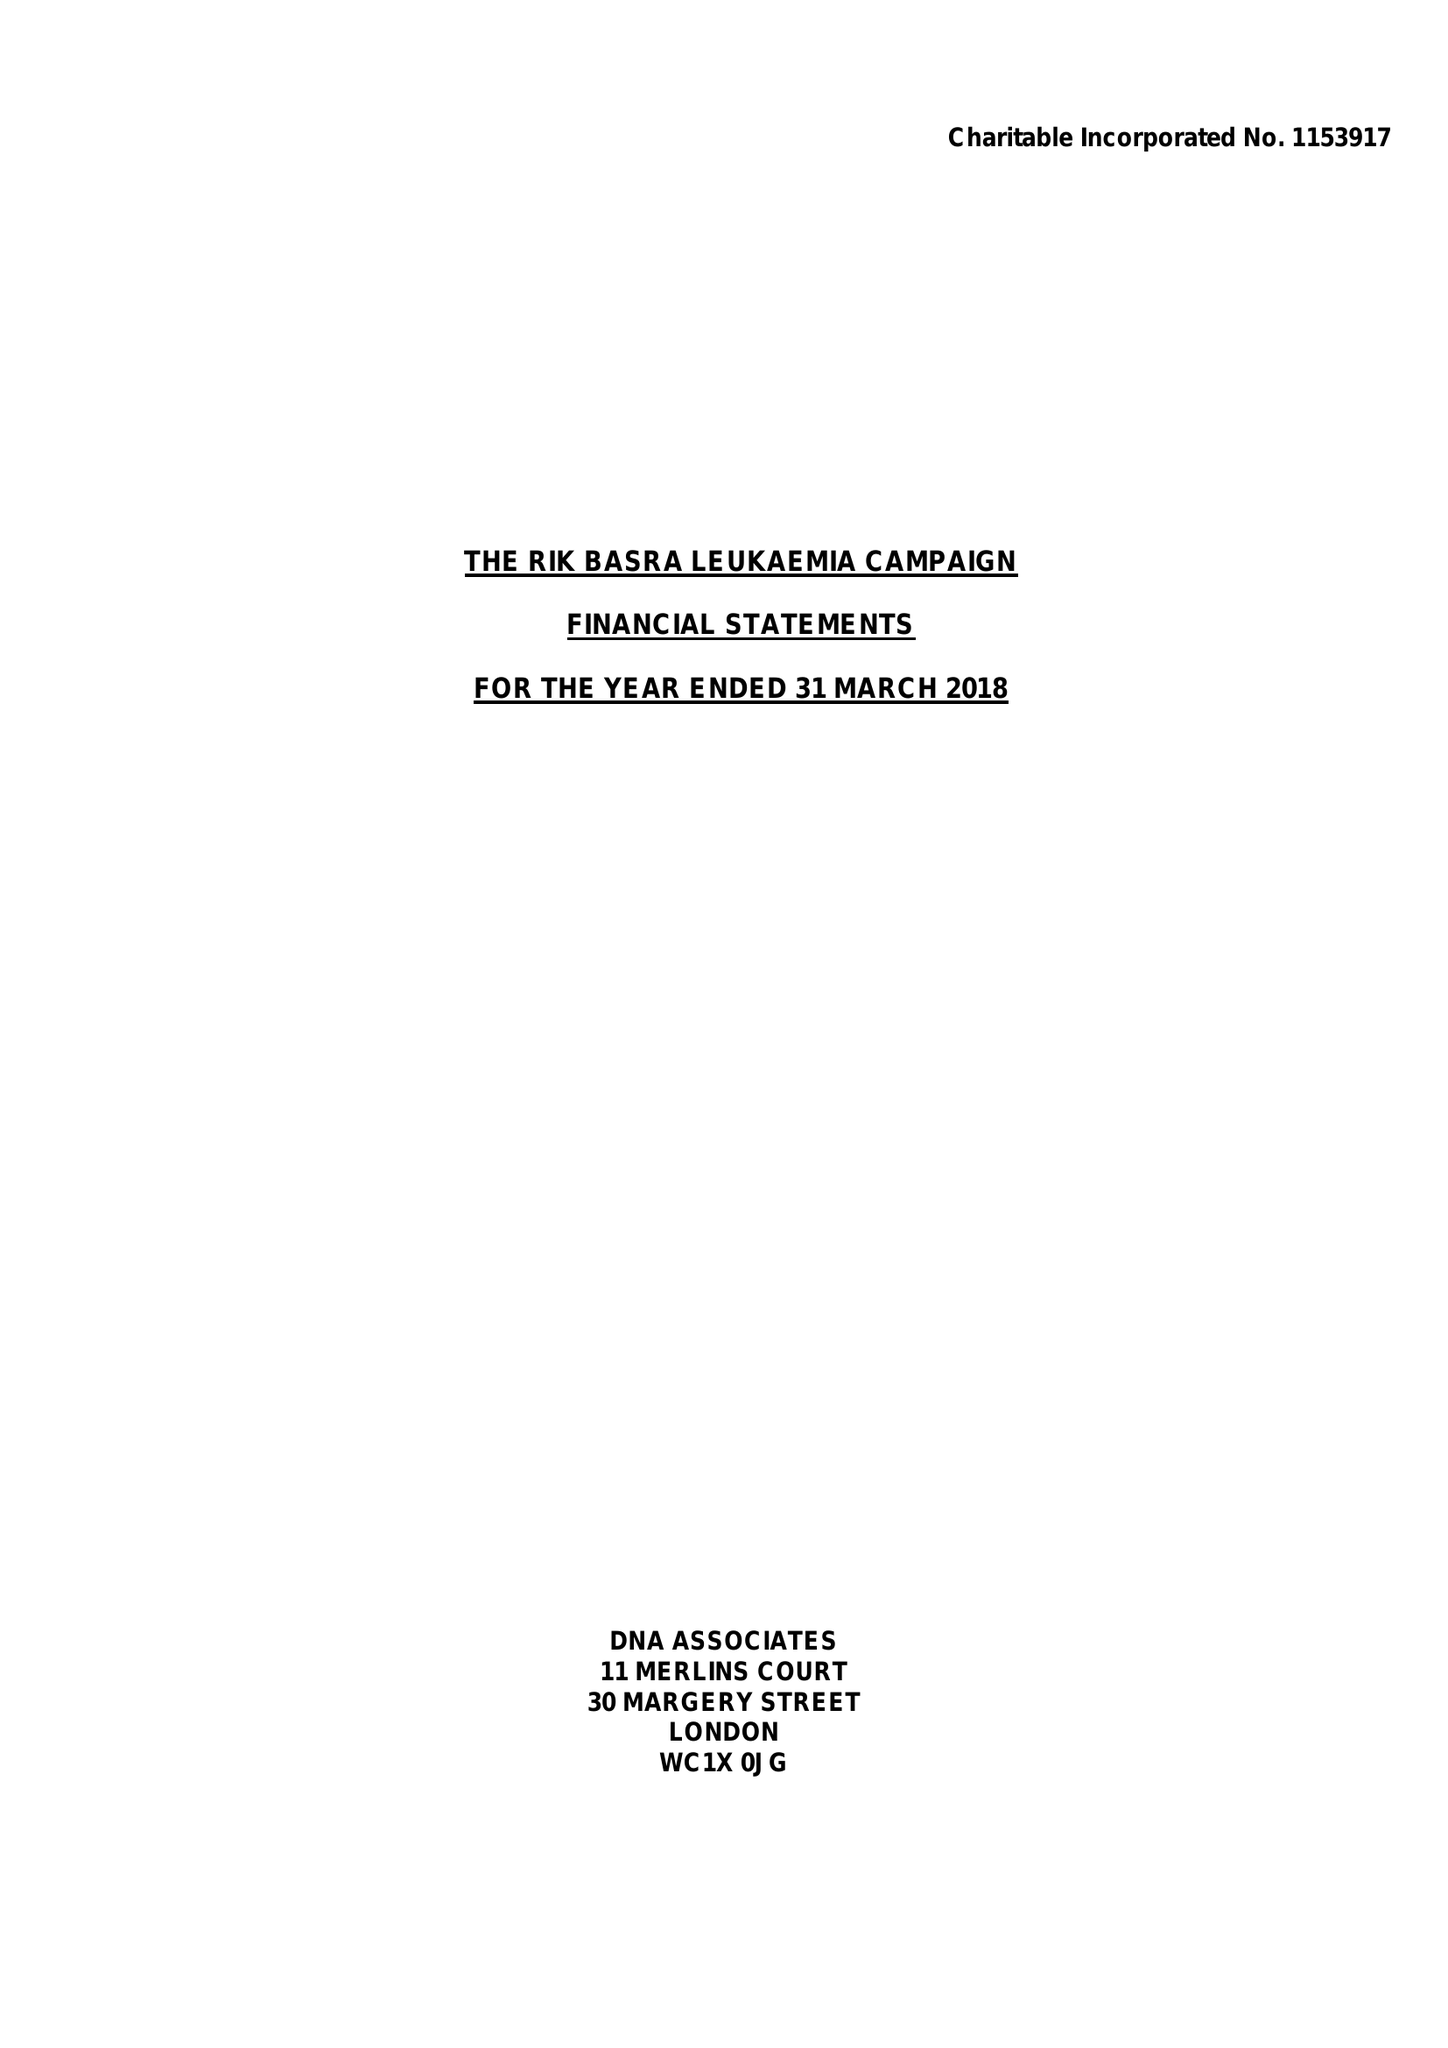What is the value for the income_annually_in_british_pounds?
Answer the question using a single word or phrase. 10000.00 